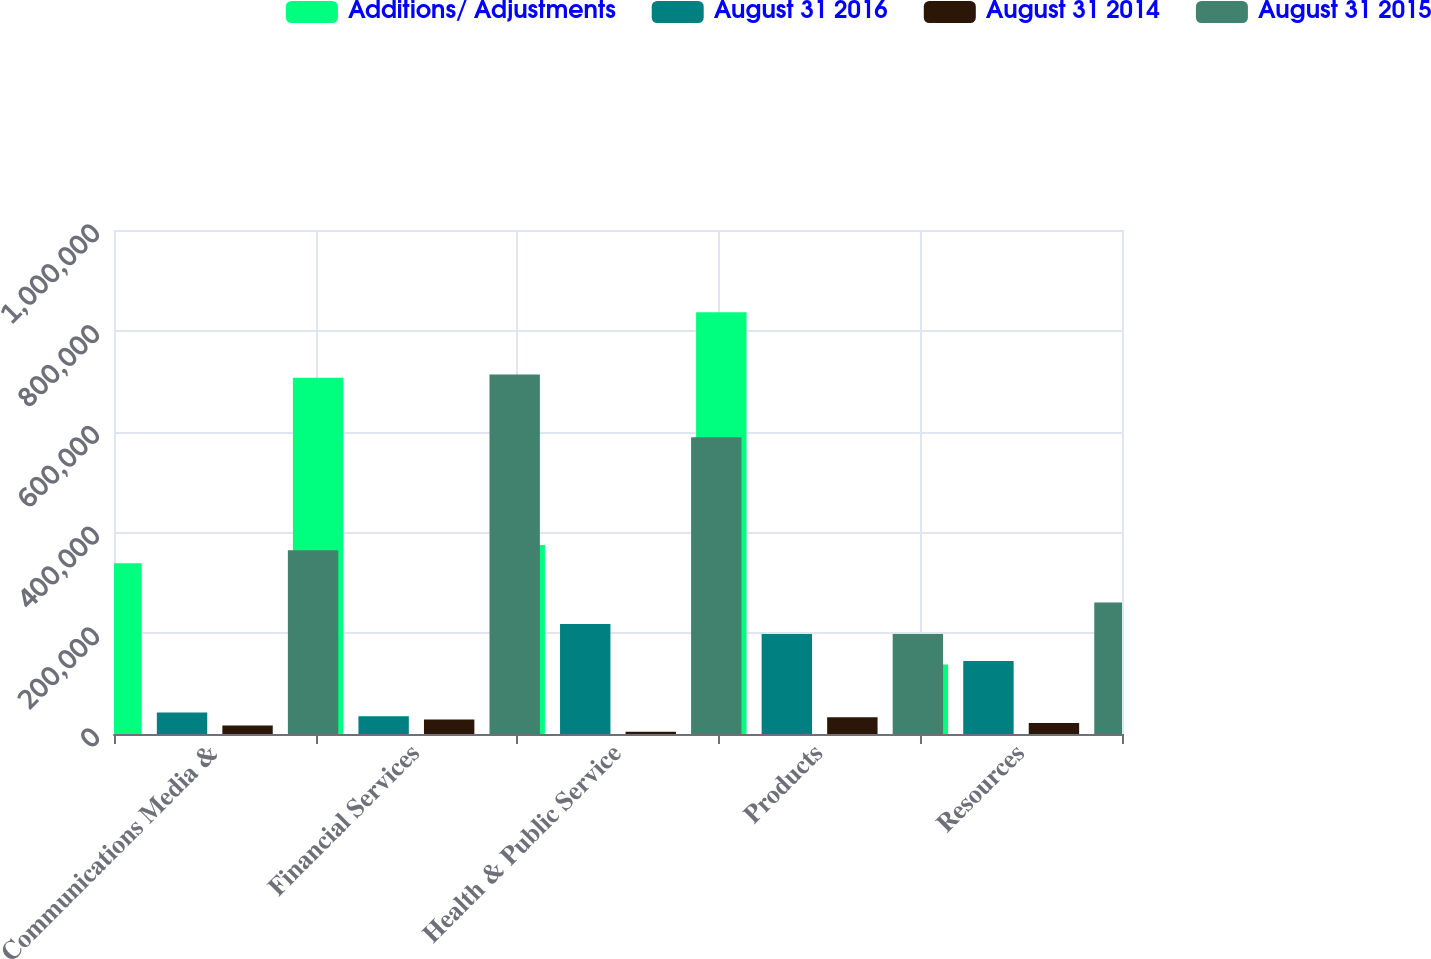Convert chart. <chart><loc_0><loc_0><loc_500><loc_500><stacked_bar_chart><ecel><fcel>Communications Media &<fcel>Financial Services<fcel>Health & Public Service<fcel>Products<fcel>Resources<nl><fcel>Additions/ Adjustments<fcel>338855<fcel>707093<fcel>375052<fcel>836858<fcel>138036<nl><fcel>August 31 2016<fcel>42797<fcel>35060<fcel>218461<fcel>198274<fcel>144844<nl><fcel>August 31 2014<fcel>16828<fcel>28723<fcel>4620<fcel>33364<fcel>21962<nl><fcel>August 31 2015<fcel>364824<fcel>713430<fcel>588893<fcel>198274<fcel>260918<nl></chart> 